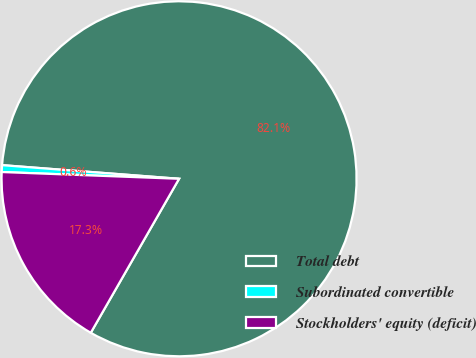<chart> <loc_0><loc_0><loc_500><loc_500><pie_chart><fcel>Total debt<fcel>Subordinated convertible<fcel>Stockholders' equity (deficit)<nl><fcel>82.06%<fcel>0.62%<fcel>17.32%<nl></chart> 